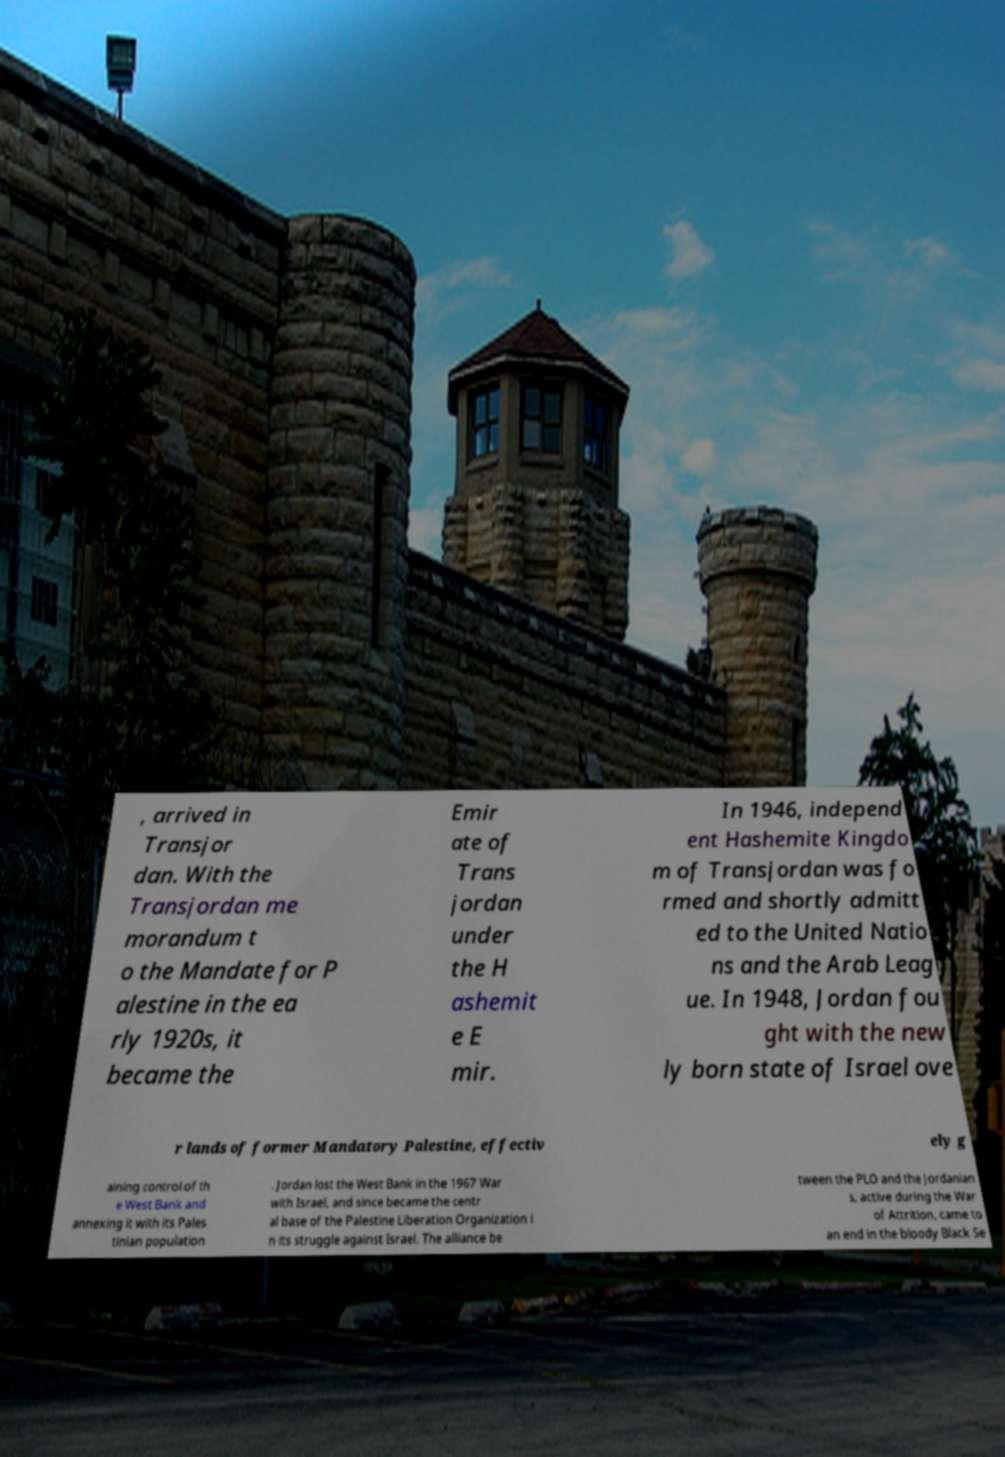What messages or text are displayed in this image? I need them in a readable, typed format. , arrived in Transjor dan. With the Transjordan me morandum t o the Mandate for P alestine in the ea rly 1920s, it became the Emir ate of Trans jordan under the H ashemit e E mir. In 1946, independ ent Hashemite Kingdo m of Transjordan was fo rmed and shortly admitt ed to the United Natio ns and the Arab Leag ue. In 1948, Jordan fou ght with the new ly born state of Israel ove r lands of former Mandatory Palestine, effectiv ely g aining control of th e West Bank and annexing it with its Pales tinian population . Jordan lost the West Bank in the 1967 War with Israel, and since became the centr al base of the Palestine Liberation Organization i n its struggle against Israel. The alliance be tween the PLO and the Jordanian s, active during the War of Attrition, came to an end in the bloody Black Se 